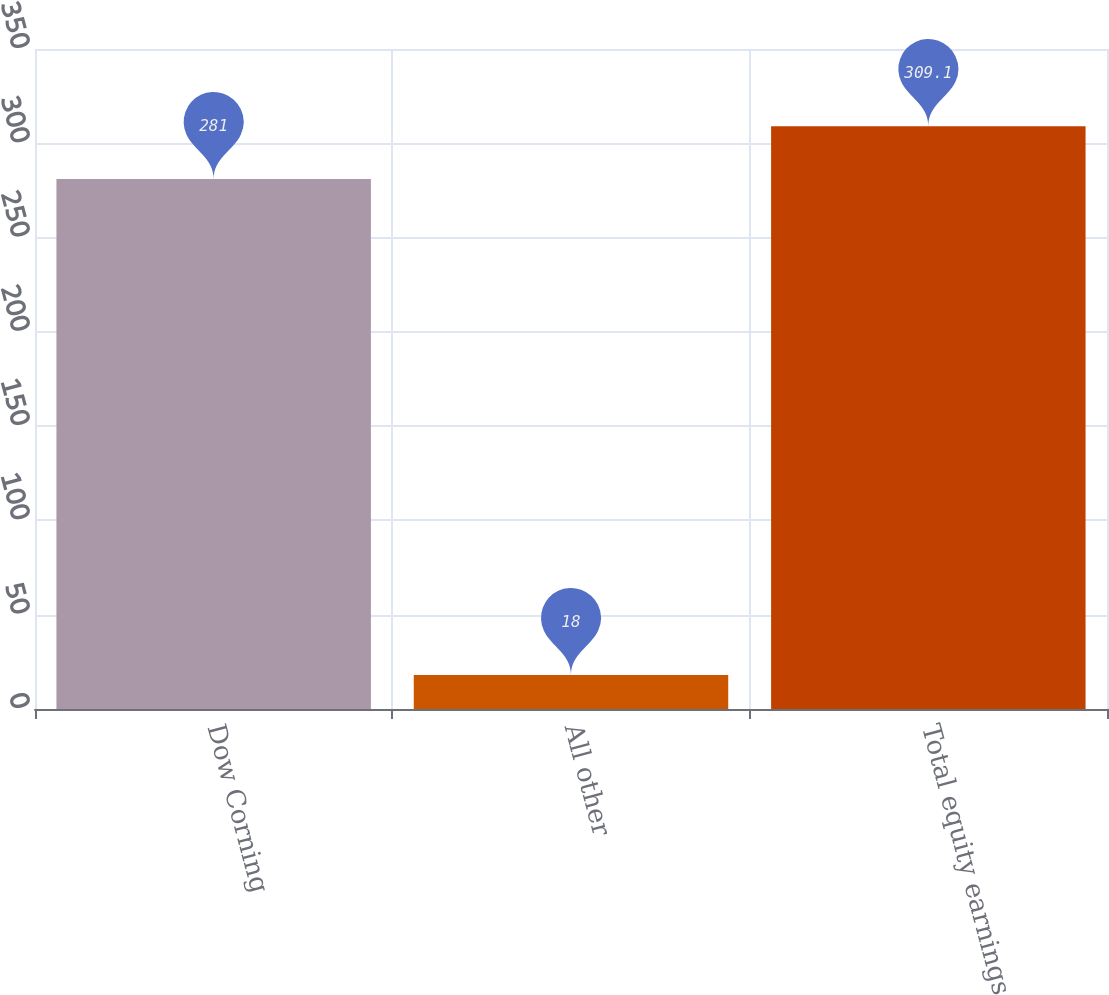Convert chart. <chart><loc_0><loc_0><loc_500><loc_500><bar_chart><fcel>Dow Corning<fcel>All other<fcel>Total equity earnings<nl><fcel>281<fcel>18<fcel>309.1<nl></chart> 